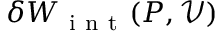<formula> <loc_0><loc_0><loc_500><loc_500>\delta W _ { i n t } ( P , \mathcal { V } )</formula> 